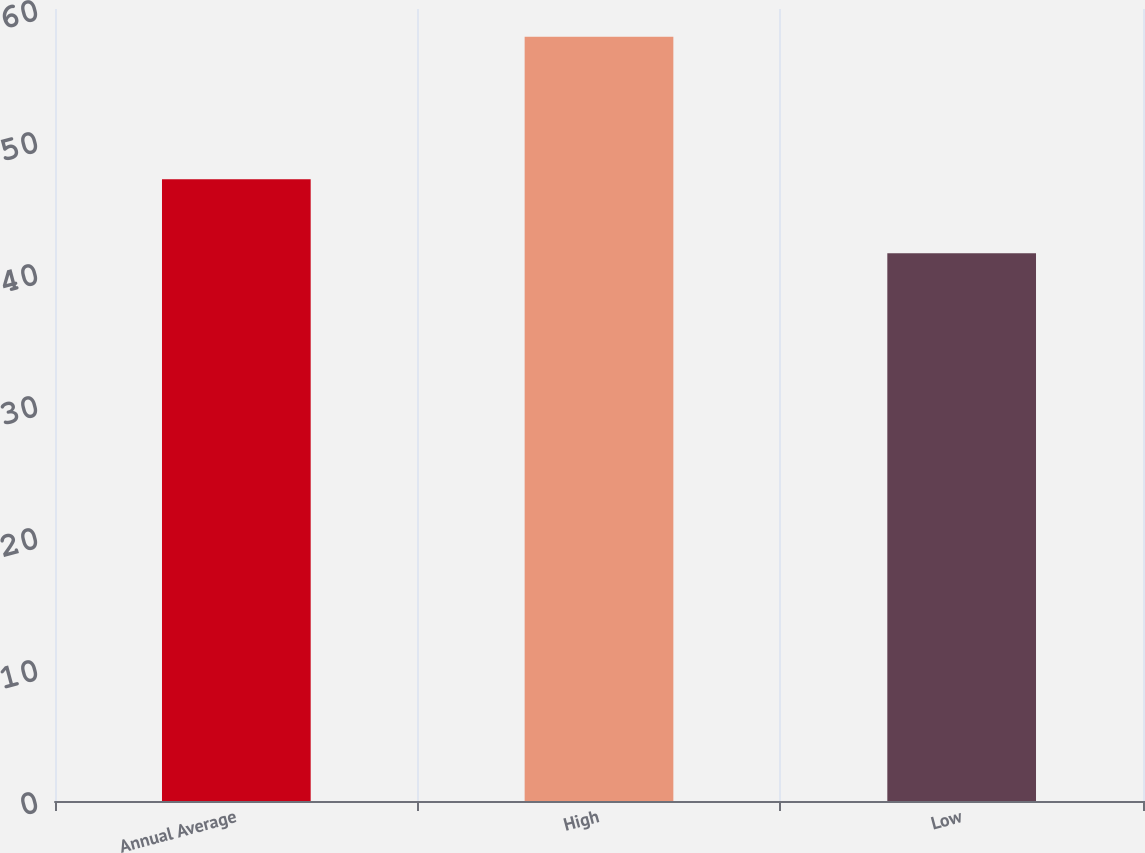Convert chart. <chart><loc_0><loc_0><loc_500><loc_500><bar_chart><fcel>Annual Average<fcel>High<fcel>Low<nl><fcel>47.1<fcel>57.9<fcel>41.5<nl></chart> 